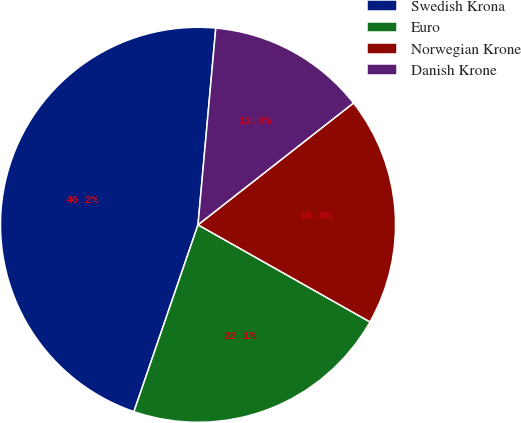Convert chart to OTSL. <chart><loc_0><loc_0><loc_500><loc_500><pie_chart><fcel>Swedish Krona<fcel>Euro<fcel>Norwegian Krone<fcel>Danish Krone<nl><fcel>46.18%<fcel>22.08%<fcel>18.76%<fcel>12.99%<nl></chart> 